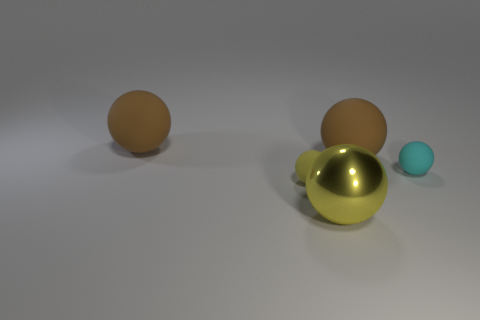What could the different textures imply about the materials represented? The textures provide cues about the materials. The brown objects have a matte finish, suggesting a soft, possibly rubberlike material that absorbs light. The metallic sphere has a glossy, reflective surface, indicating a hard and smooth material like metal that reflects light and its surroundings. The teal sphere, although small, has a texture that seems slightly reflective yet not as lustrous as the metallic sphere, hinting at a plastic or ceramic material. 